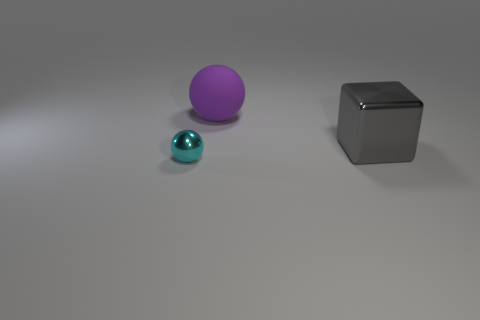How many other things are there of the same material as the small cyan object?
Your answer should be compact. 1. There is a ball in front of the gray block; is its color the same as the object that is behind the block?
Keep it short and to the point. No. There is a big thing behind the metallic thing that is to the right of the shiny sphere; what shape is it?
Keep it short and to the point. Sphere. Do the ball that is on the right side of the cyan metallic ball and the thing that is in front of the gray cube have the same material?
Provide a short and direct response. No. There is a metallic thing to the left of the big gray metal thing; what size is it?
Your answer should be compact. Small. There is another large thing that is the same shape as the cyan metal object; what material is it?
Offer a very short reply. Rubber. Is there anything else that is the same size as the gray block?
Ensure brevity in your answer.  Yes. The big thing behind the shiny block has what shape?
Offer a terse response. Sphere. How many metal things are the same shape as the rubber thing?
Provide a short and direct response. 1. Are there an equal number of small cyan metal balls to the right of the small object and big balls right of the big purple rubber object?
Offer a very short reply. Yes. 